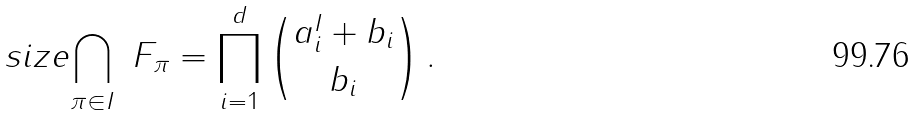Convert formula to latex. <formula><loc_0><loc_0><loc_500><loc_500>\ s i z e { \bigcap _ { \pi \in I } \ F _ { \pi } } = \prod _ { i = 1 } ^ { d } \binom { a ^ { I } _ { i } + b _ { i } } { b _ { i } } \, .</formula> 